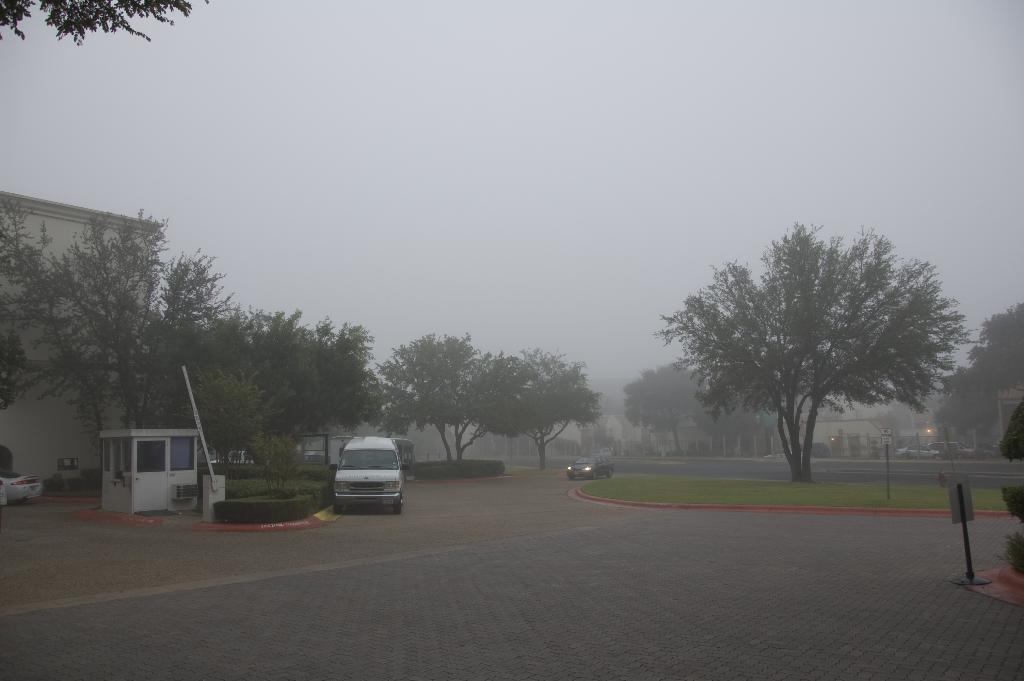What type of structures can be seen in the image? There are houses in the image. What type of vegetation is present in the image? There are trees, plants, and grass in the image. What else can be seen in the image besides structures and vegetation? There are objects, vehicles on the road, and lights in the image. What part of the natural environment is visible in the image? The sky is visible in the image. How is the background of the image depicted? The background portion of the image is blurred. How many giants are holding the glass in the image? There are no giants or glass present in the image. What type of beast can be seen roaming in the background of the image? There are no beasts present in the image; the background is blurred and only shows the sky. 